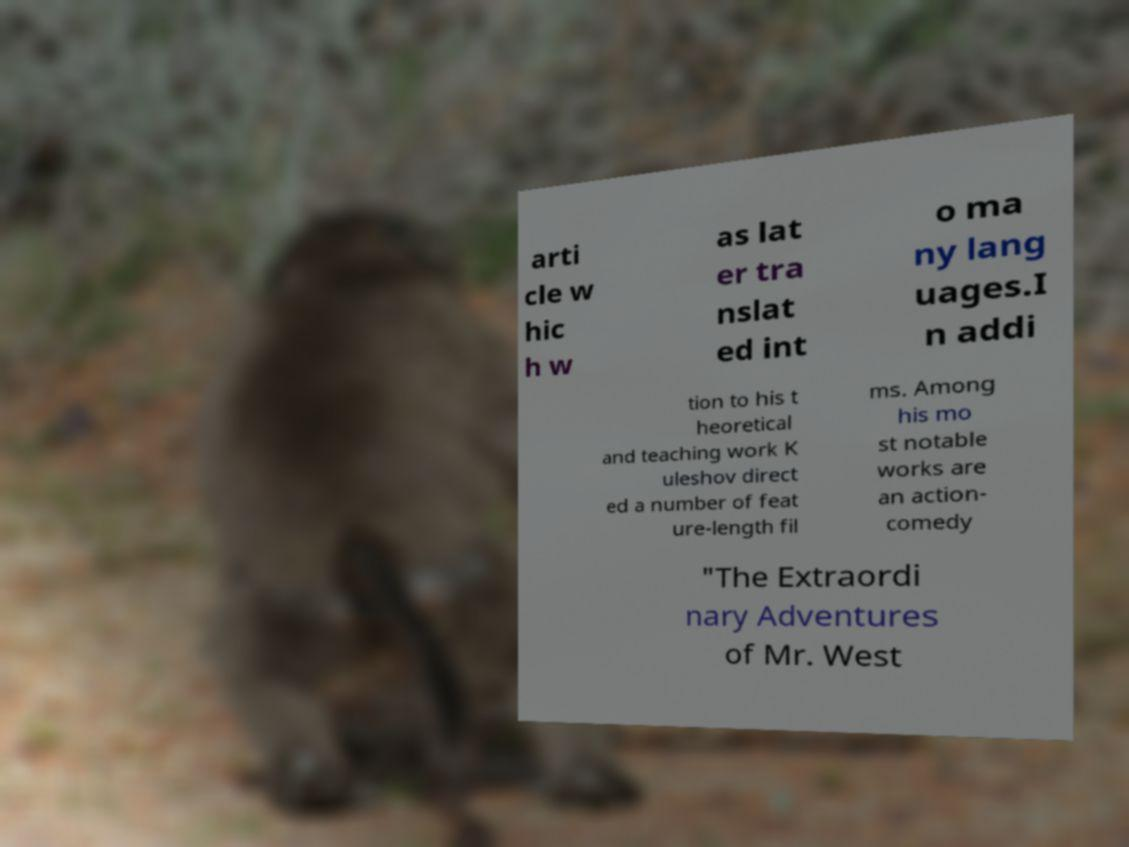Could you assist in decoding the text presented in this image and type it out clearly? arti cle w hic h w as lat er tra nslat ed int o ma ny lang uages.I n addi tion to his t heoretical and teaching work K uleshov direct ed a number of feat ure-length fil ms. Among his mo st notable works are an action- comedy "The Extraordi nary Adventures of Mr. West 